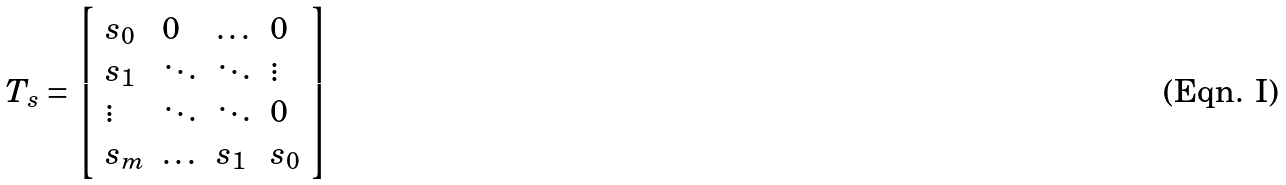Convert formula to latex. <formula><loc_0><loc_0><loc_500><loc_500>T _ { s } = \left [ \begin{array} { l l l l } s _ { 0 } & 0 & \dots & 0 \\ s _ { 1 } & \ddots & \ddots & \vdots \\ \vdots & \ddots & \ddots & 0 \\ s _ { m } & \dots & s _ { 1 } & s _ { 0 } \end{array} \right ]</formula> 